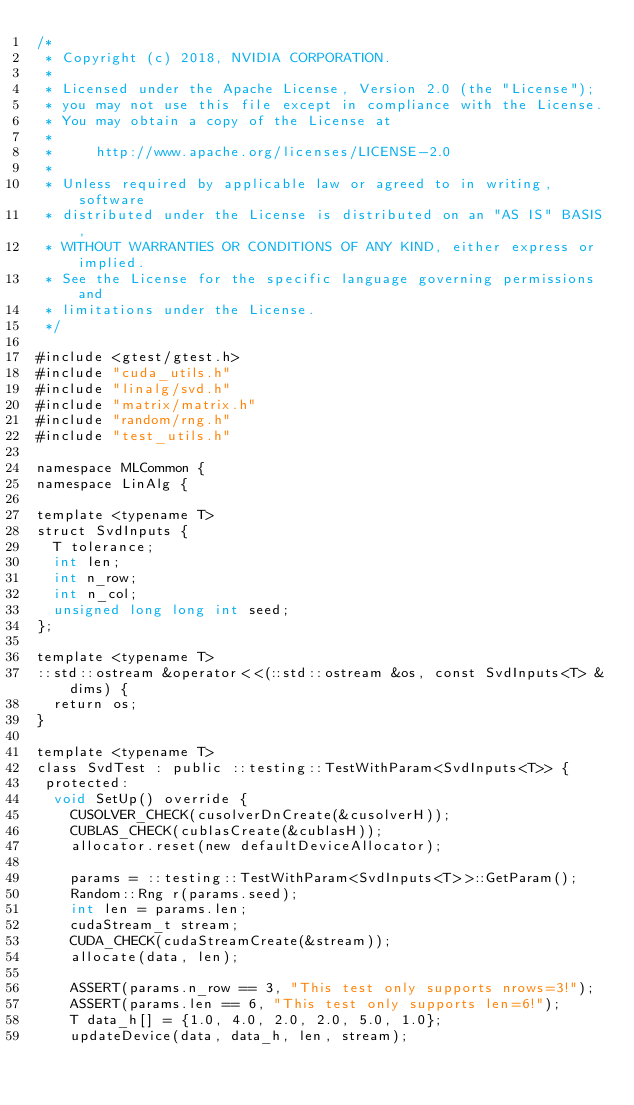<code> <loc_0><loc_0><loc_500><loc_500><_Cuda_>/*
 * Copyright (c) 2018, NVIDIA CORPORATION.
 *
 * Licensed under the Apache License, Version 2.0 (the "License");
 * you may not use this file except in compliance with the License.
 * You may obtain a copy of the License at
 *
 *     http://www.apache.org/licenses/LICENSE-2.0
 *
 * Unless required by applicable law or agreed to in writing, software
 * distributed under the License is distributed on an "AS IS" BASIS,
 * WITHOUT WARRANTIES OR CONDITIONS OF ANY KIND, either express or implied.
 * See the License for the specific language governing permissions and
 * limitations under the License.
 */

#include <gtest/gtest.h>
#include "cuda_utils.h"
#include "linalg/svd.h"
#include "matrix/matrix.h"
#include "random/rng.h"
#include "test_utils.h"

namespace MLCommon {
namespace LinAlg {

template <typename T>
struct SvdInputs {
  T tolerance;
  int len;
  int n_row;
  int n_col;
  unsigned long long int seed;
};

template <typename T>
::std::ostream &operator<<(::std::ostream &os, const SvdInputs<T> &dims) {
  return os;
}

template <typename T>
class SvdTest : public ::testing::TestWithParam<SvdInputs<T>> {
 protected:
  void SetUp() override {
    CUSOLVER_CHECK(cusolverDnCreate(&cusolverH));
    CUBLAS_CHECK(cublasCreate(&cublasH));
    allocator.reset(new defaultDeviceAllocator);

    params = ::testing::TestWithParam<SvdInputs<T>>::GetParam();
    Random::Rng r(params.seed);
    int len = params.len;
    cudaStream_t stream;
    CUDA_CHECK(cudaStreamCreate(&stream));
    allocate(data, len);

    ASSERT(params.n_row == 3, "This test only supports nrows=3!");
    ASSERT(params.len == 6, "This test only supports len=6!");
    T data_h[] = {1.0, 4.0, 2.0, 2.0, 5.0, 1.0};
    updateDevice(data, data_h, len, stream);
</code> 